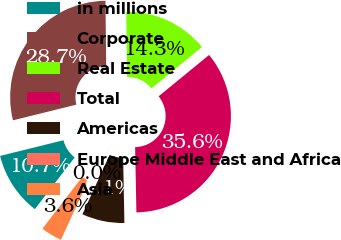Convert chart. <chart><loc_0><loc_0><loc_500><loc_500><pie_chart><fcel>in millions<fcel>Corporate<fcel>Real Estate<fcel>Total<fcel>Americas<fcel>Europe Middle East and Africa<fcel>Asia<nl><fcel>10.7%<fcel>28.68%<fcel>14.26%<fcel>35.61%<fcel>7.14%<fcel>0.03%<fcel>3.58%<nl></chart> 